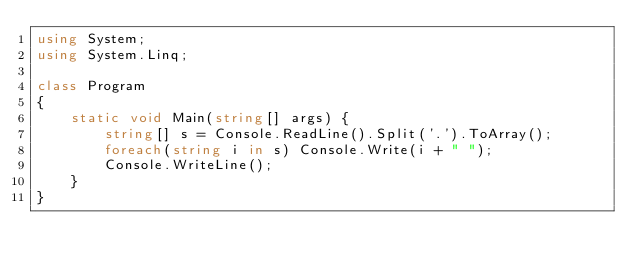Convert code to text. <code><loc_0><loc_0><loc_500><loc_500><_C#_>using System;
using System.Linq;

class Program 
{
    static void Main(string[] args) {
        string[] s = Console.ReadLine().Split('.').ToArray();
        foreach(string i in s) Console.Write(i + " ");
        Console.WriteLine();
    }
}</code> 